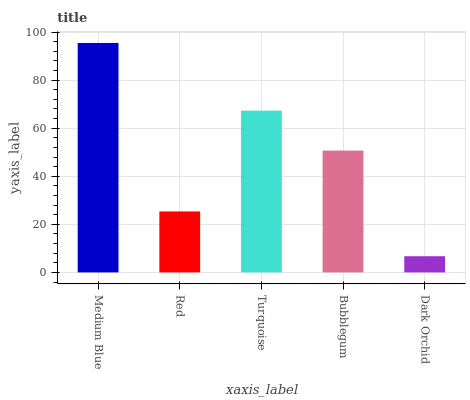Is Dark Orchid the minimum?
Answer yes or no. Yes. Is Medium Blue the maximum?
Answer yes or no. Yes. Is Red the minimum?
Answer yes or no. No. Is Red the maximum?
Answer yes or no. No. Is Medium Blue greater than Red?
Answer yes or no. Yes. Is Red less than Medium Blue?
Answer yes or no. Yes. Is Red greater than Medium Blue?
Answer yes or no. No. Is Medium Blue less than Red?
Answer yes or no. No. Is Bubblegum the high median?
Answer yes or no. Yes. Is Bubblegum the low median?
Answer yes or no. Yes. Is Dark Orchid the high median?
Answer yes or no. No. Is Medium Blue the low median?
Answer yes or no. No. 